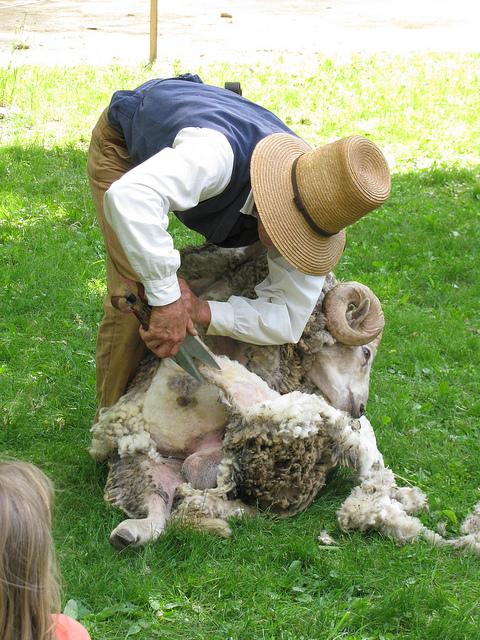What animal is this?
Answer briefly. Sheep. What do these guys doing to the animals?
Keep it brief. Shearing. What device is the man holding?
Concise answer only. Shears. What is the man doing?
Quick response, please. Shearing sheep. 